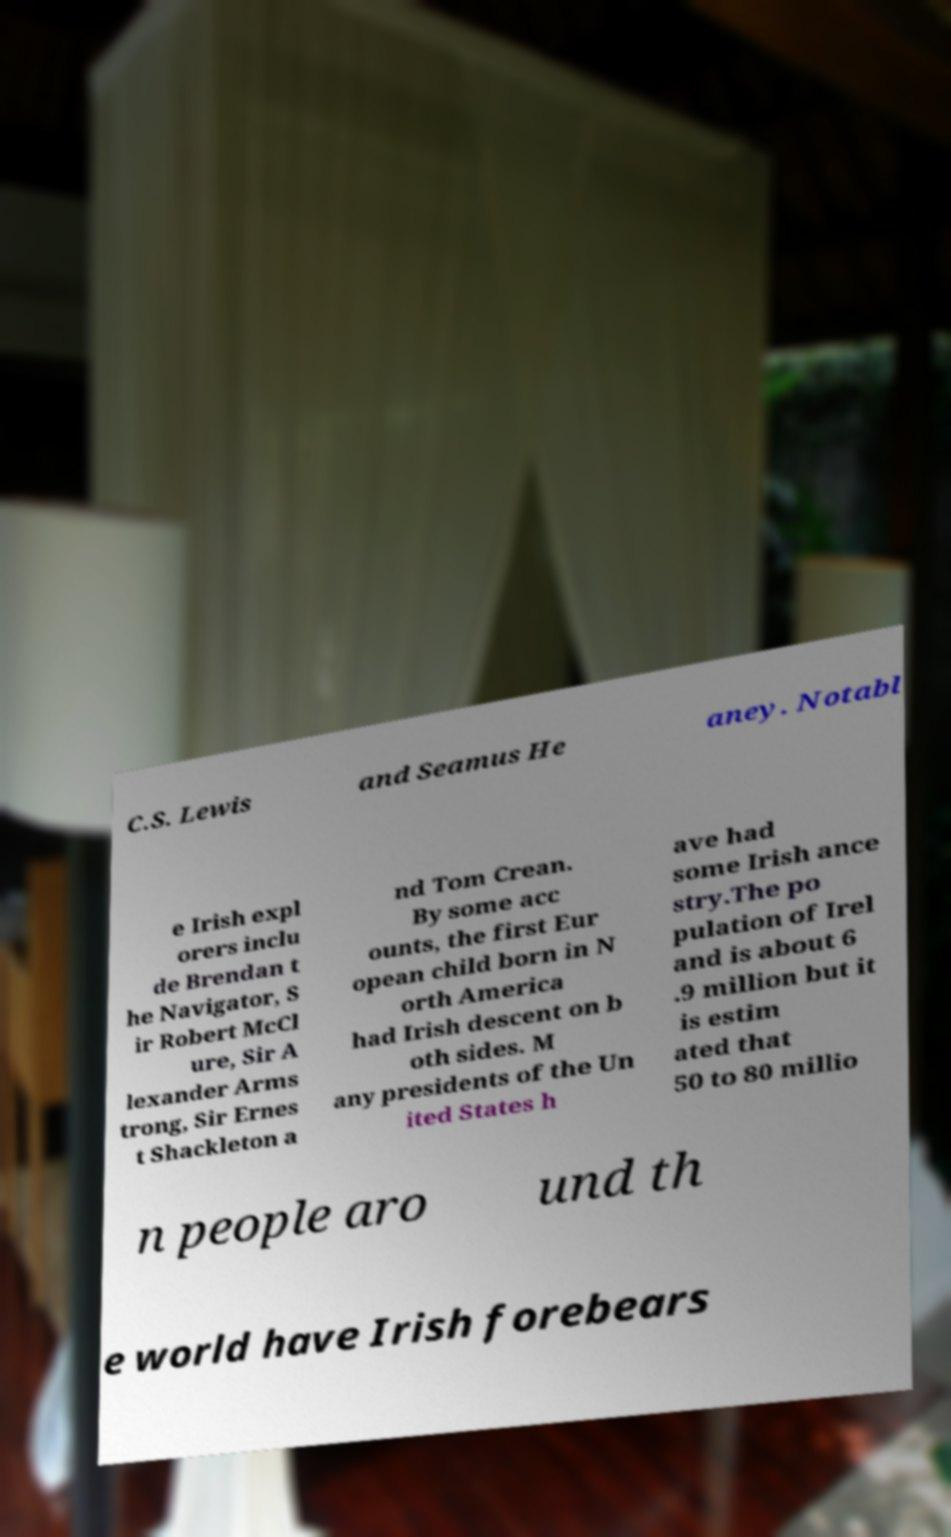I need the written content from this picture converted into text. Can you do that? C.S. Lewis and Seamus He aney. Notabl e Irish expl orers inclu de Brendan t he Navigator, S ir Robert McCl ure, Sir A lexander Arms trong, Sir Ernes t Shackleton a nd Tom Crean. By some acc ounts, the first Eur opean child born in N orth America had Irish descent on b oth sides. M any presidents of the Un ited States h ave had some Irish ance stry.The po pulation of Irel and is about 6 .9 million but it is estim ated that 50 to 80 millio n people aro und th e world have Irish forebears 